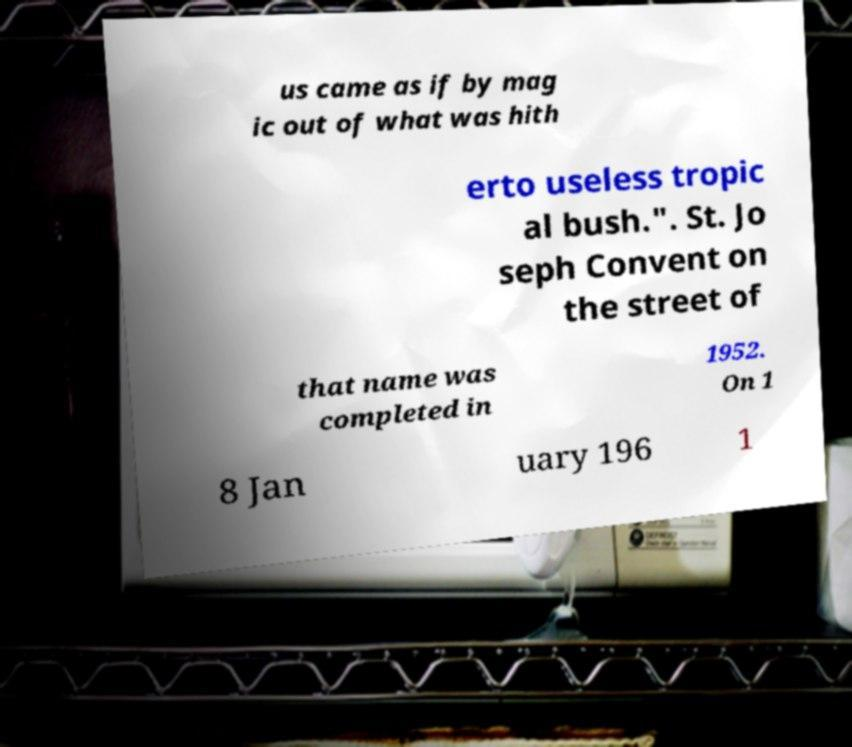Could you assist in decoding the text presented in this image and type it out clearly? us came as if by mag ic out of what was hith erto useless tropic al bush.". St. Jo seph Convent on the street of that name was completed in 1952. On 1 8 Jan uary 196 1 